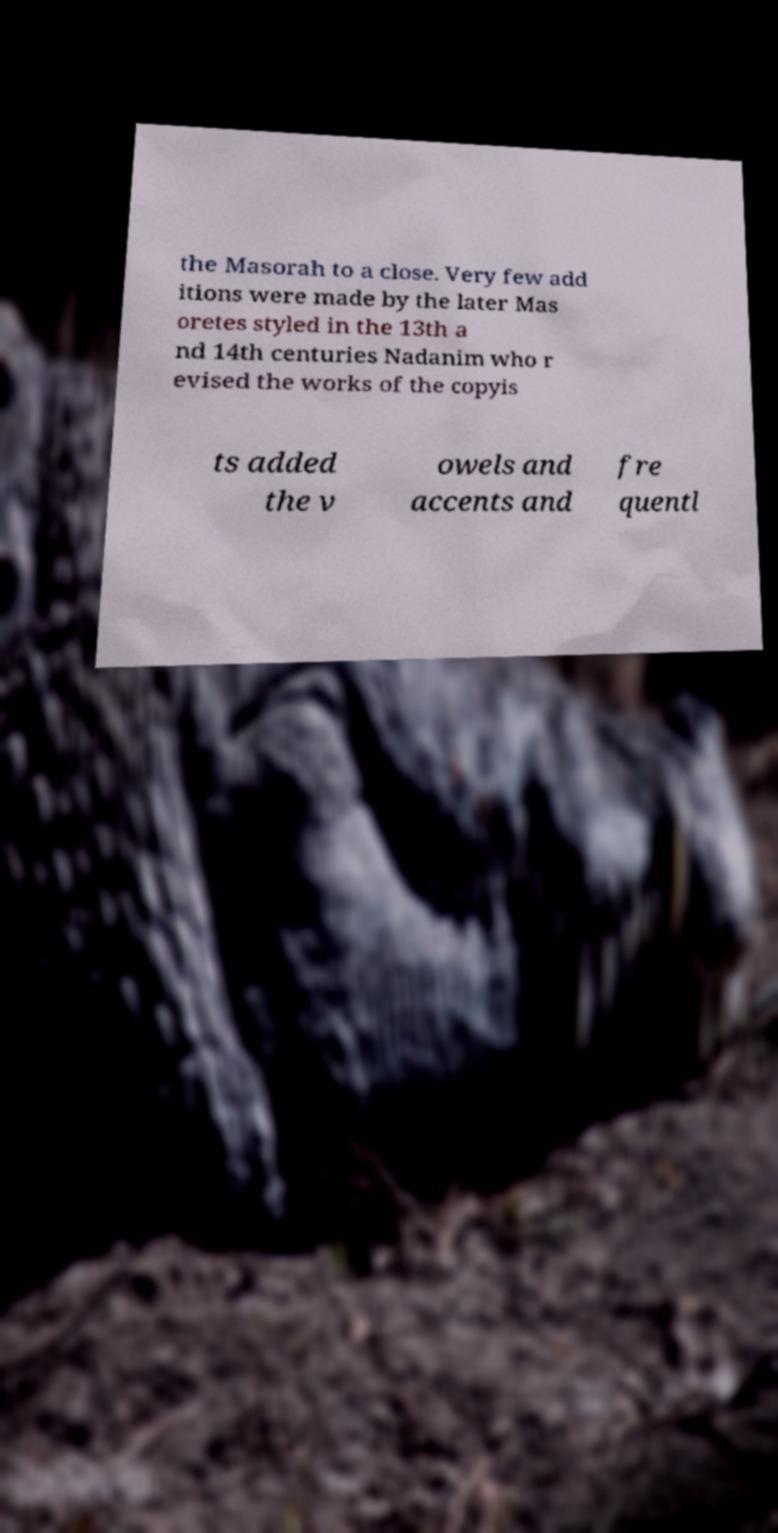There's text embedded in this image that I need extracted. Can you transcribe it verbatim? the Masorah to a close. Very few add itions were made by the later Mas oretes styled in the 13th a nd 14th centuries Nadanim who r evised the works of the copyis ts added the v owels and accents and fre quentl 